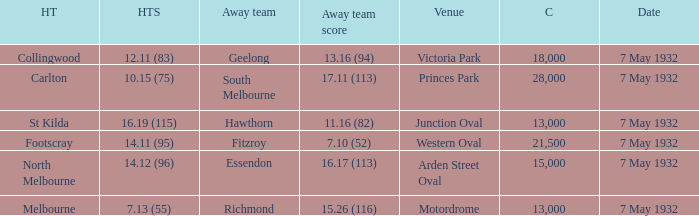What is the away team with a Crowd greater than 13,000, and a Home team score of 12.11 (83)? Geelong. 